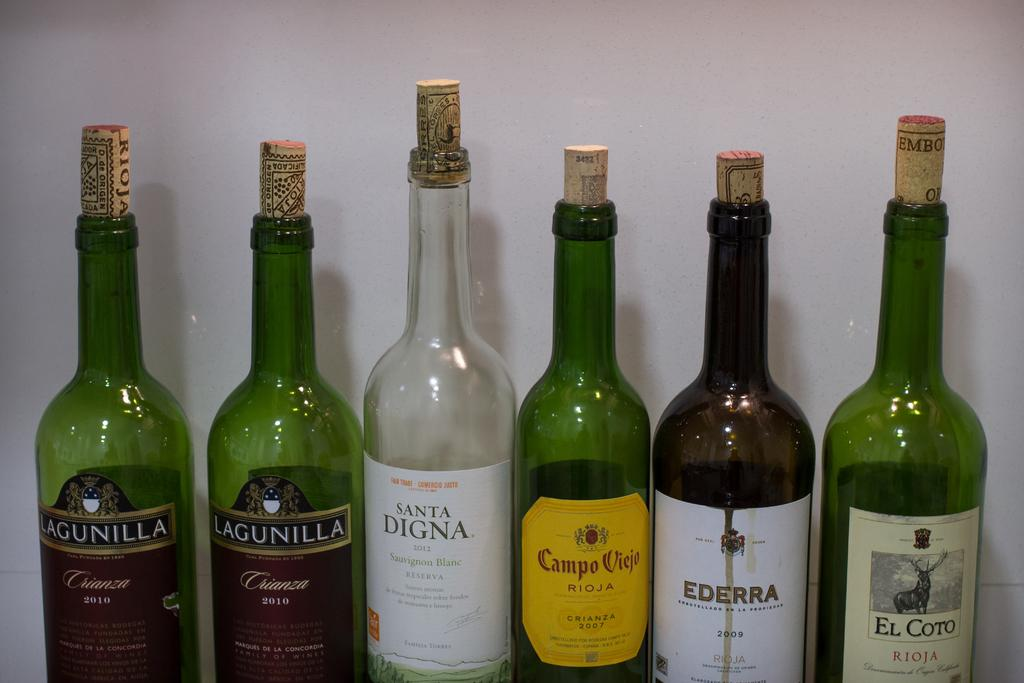<image>
Present a compact description of the photo's key features. Corked bottles of wine are in a row including a Santa Digna sauvignon blanc. 